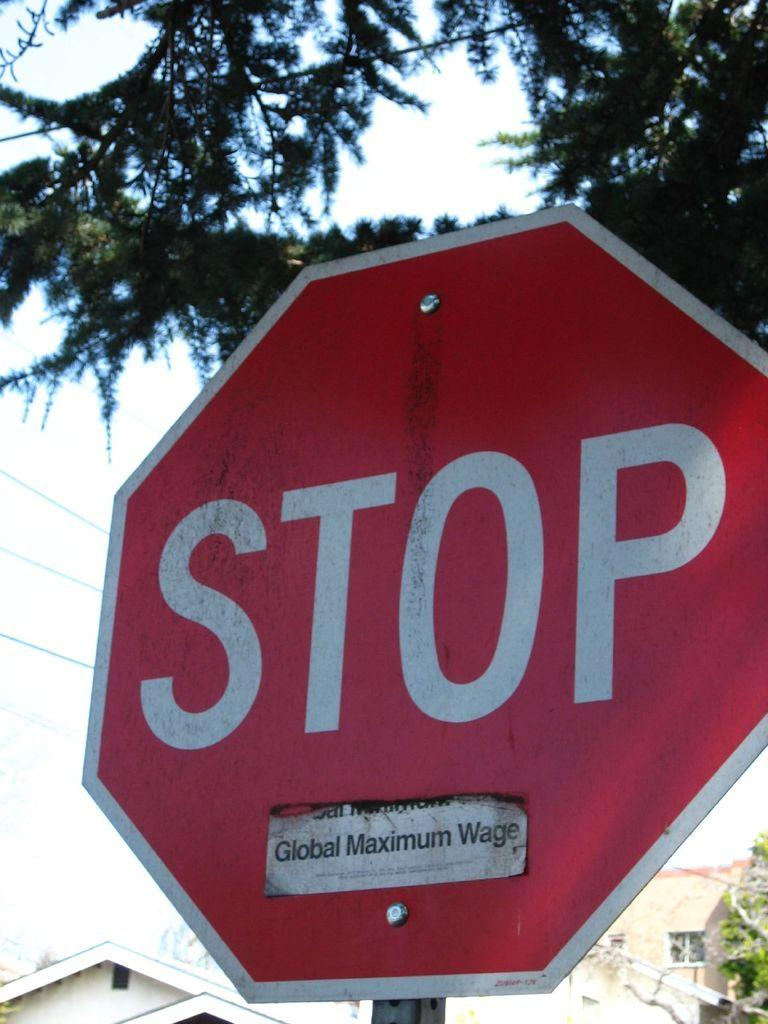<image>
Describe the image concisely. A stop sign with a global maximum wage sticker on it. 